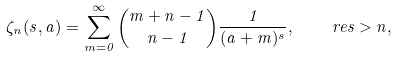<formula> <loc_0><loc_0><loc_500><loc_500>\zeta _ { n } ( s , a ) = \sum _ { m = 0 } ^ { \infty } \binom { m + n - 1 } { n - 1 } \frac { 1 } { ( a + m ) ^ { s } } , \quad \ r e { s } > n ,</formula> 